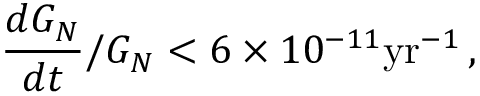Convert formula to latex. <formula><loc_0><loc_0><loc_500><loc_500>\frac { d G _ { N } } { d t } / G _ { N } < 6 \times 1 0 ^ { - 1 1 } y r ^ { - 1 } \, ,</formula> 